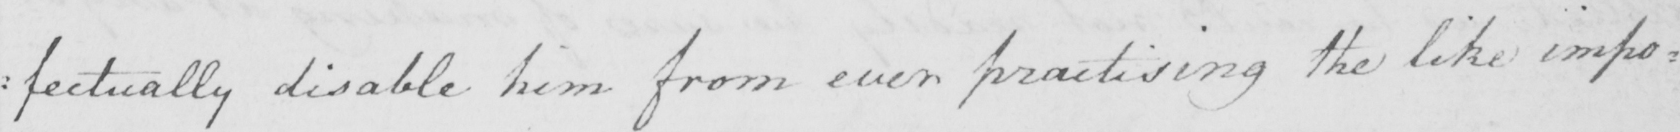Transcribe the text shown in this historical manuscript line. : fectually disable him from ever practising the like impo= 